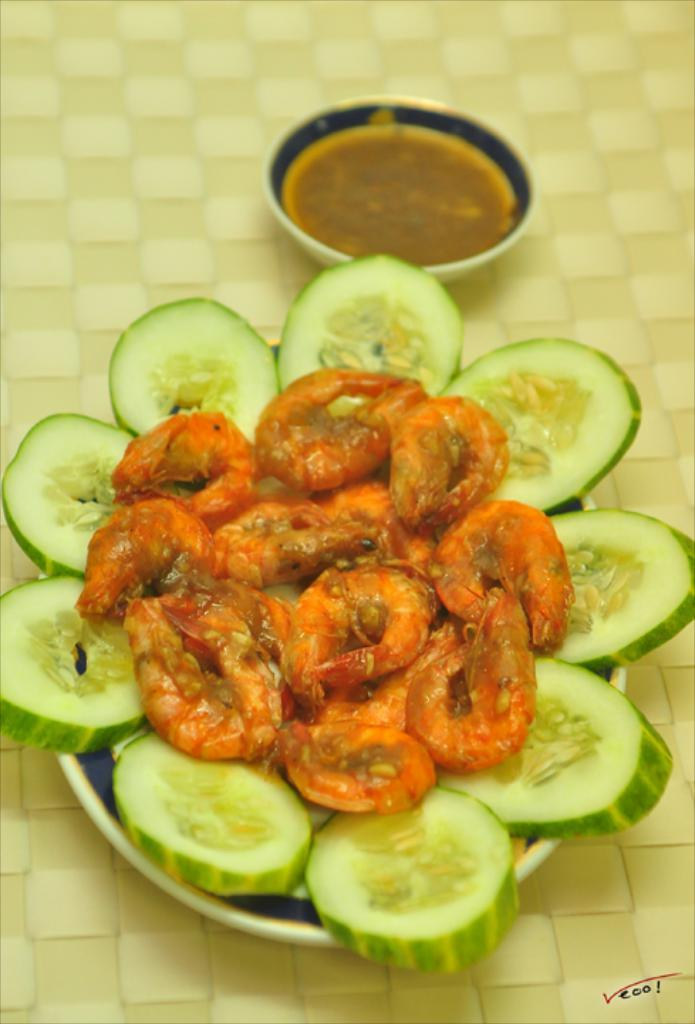What type of items can be seen in the image? The image contains food. Can you tell me how many owls are sitting on the food in the image? There are no owls present in the image; it contains only food. What type of fabric is used to make the sister's dress in the image? There is no sister or dress present in the image; it contains only food. 